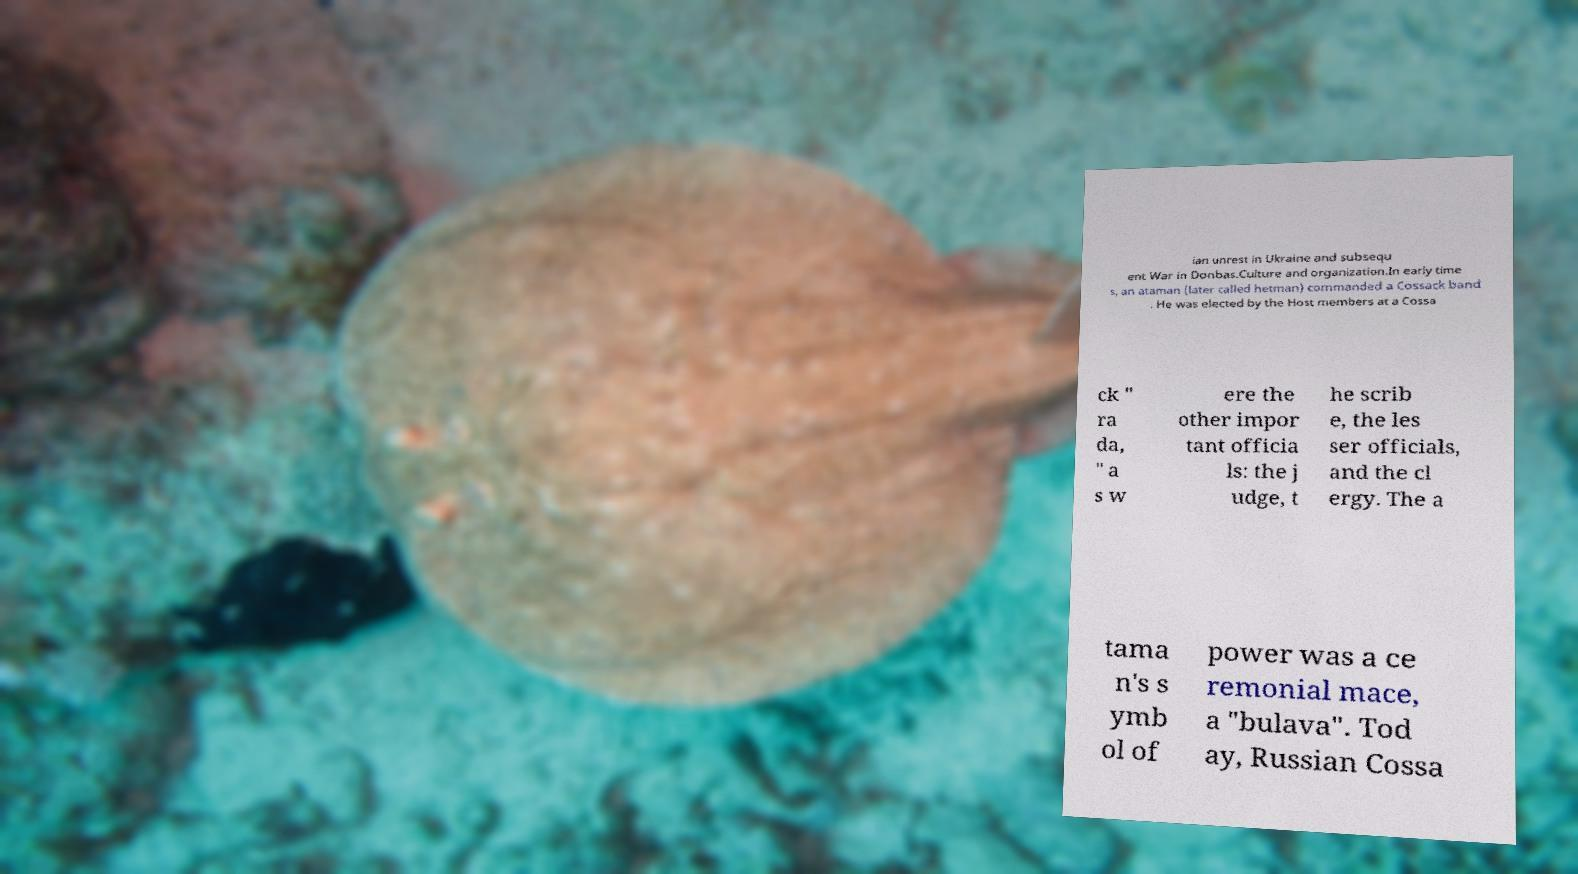I need the written content from this picture converted into text. Can you do that? ian unrest in Ukraine and subsequ ent War in Donbas.Culture and organization.In early time s, an ataman (later called hetman) commanded a Cossack band . He was elected by the Host members at a Cossa ck " ra da, " a s w ere the other impor tant officia ls: the j udge, t he scrib e, the les ser officials, and the cl ergy. The a tama n's s ymb ol of power was a ce remonial mace, a "bulava". Tod ay, Russian Cossa 